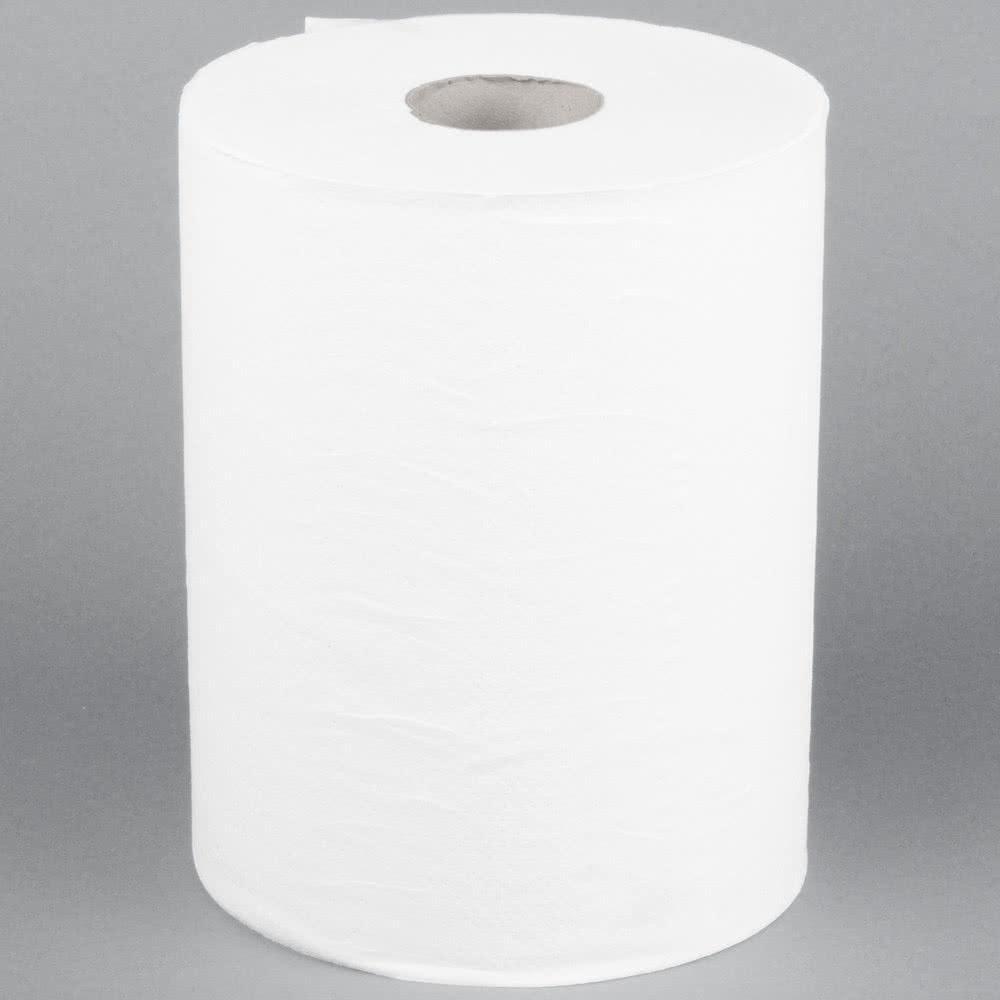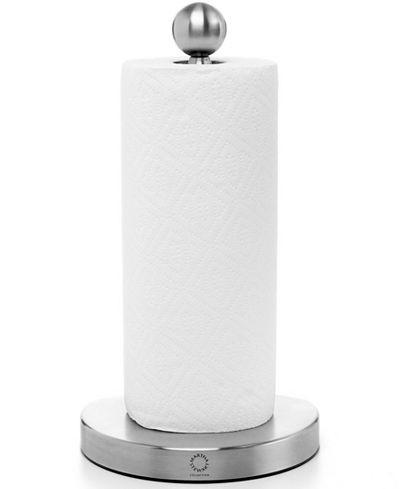The first image is the image on the left, the second image is the image on the right. Examine the images to the left and right. Is the description "One image shows a towel roll without a stand and without any sheet unfurled." accurate? Answer yes or no. Yes. The first image is the image on the left, the second image is the image on the right. Analyze the images presented: Is the assertion "Only one of the paper towel rolls is on the paper towel holder." valid? Answer yes or no. Yes. 